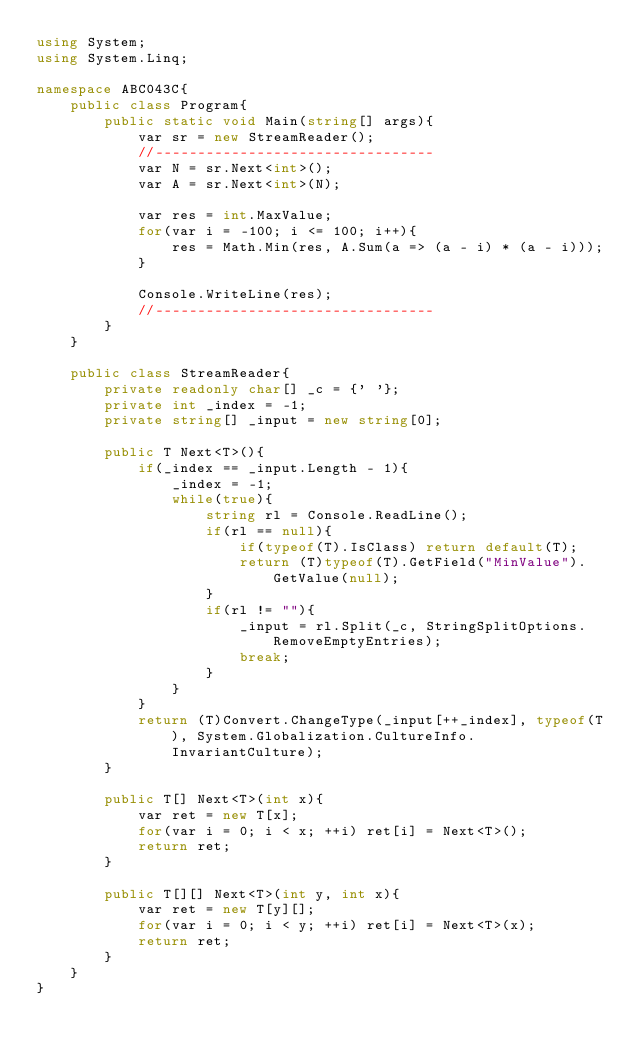Convert code to text. <code><loc_0><loc_0><loc_500><loc_500><_C#_>using System;
using System.Linq;

namespace ABC043C{
    public class Program{
        public static void Main(string[] args){
            var sr = new StreamReader();
            //---------------------------------
            var N = sr.Next<int>();
            var A = sr.Next<int>(N);

            var res = int.MaxValue;
            for(var i = -100; i <= 100; i++){
                res = Math.Min(res, A.Sum(a => (a - i) * (a - i)));
            }

            Console.WriteLine(res);
            //---------------------------------
        }
    }

    public class StreamReader{
        private readonly char[] _c = {' '};
        private int _index = -1;
        private string[] _input = new string[0];

        public T Next<T>(){
            if(_index == _input.Length - 1){
                _index = -1;
                while(true){
                    string rl = Console.ReadLine();
                    if(rl == null){
                        if(typeof(T).IsClass) return default(T);
                        return (T)typeof(T).GetField("MinValue").GetValue(null);
                    }
                    if(rl != ""){
                        _input = rl.Split(_c, StringSplitOptions.RemoveEmptyEntries);
                        break;
                    }
                }
            }
            return (T)Convert.ChangeType(_input[++_index], typeof(T), System.Globalization.CultureInfo.InvariantCulture);
        }

        public T[] Next<T>(int x){
            var ret = new T[x];
            for(var i = 0; i < x; ++i) ret[i] = Next<T>();
            return ret;
        }

        public T[][] Next<T>(int y, int x){
            var ret = new T[y][];
            for(var i = 0; i < y; ++i) ret[i] = Next<T>(x);
            return ret;
        }
    }
}</code> 